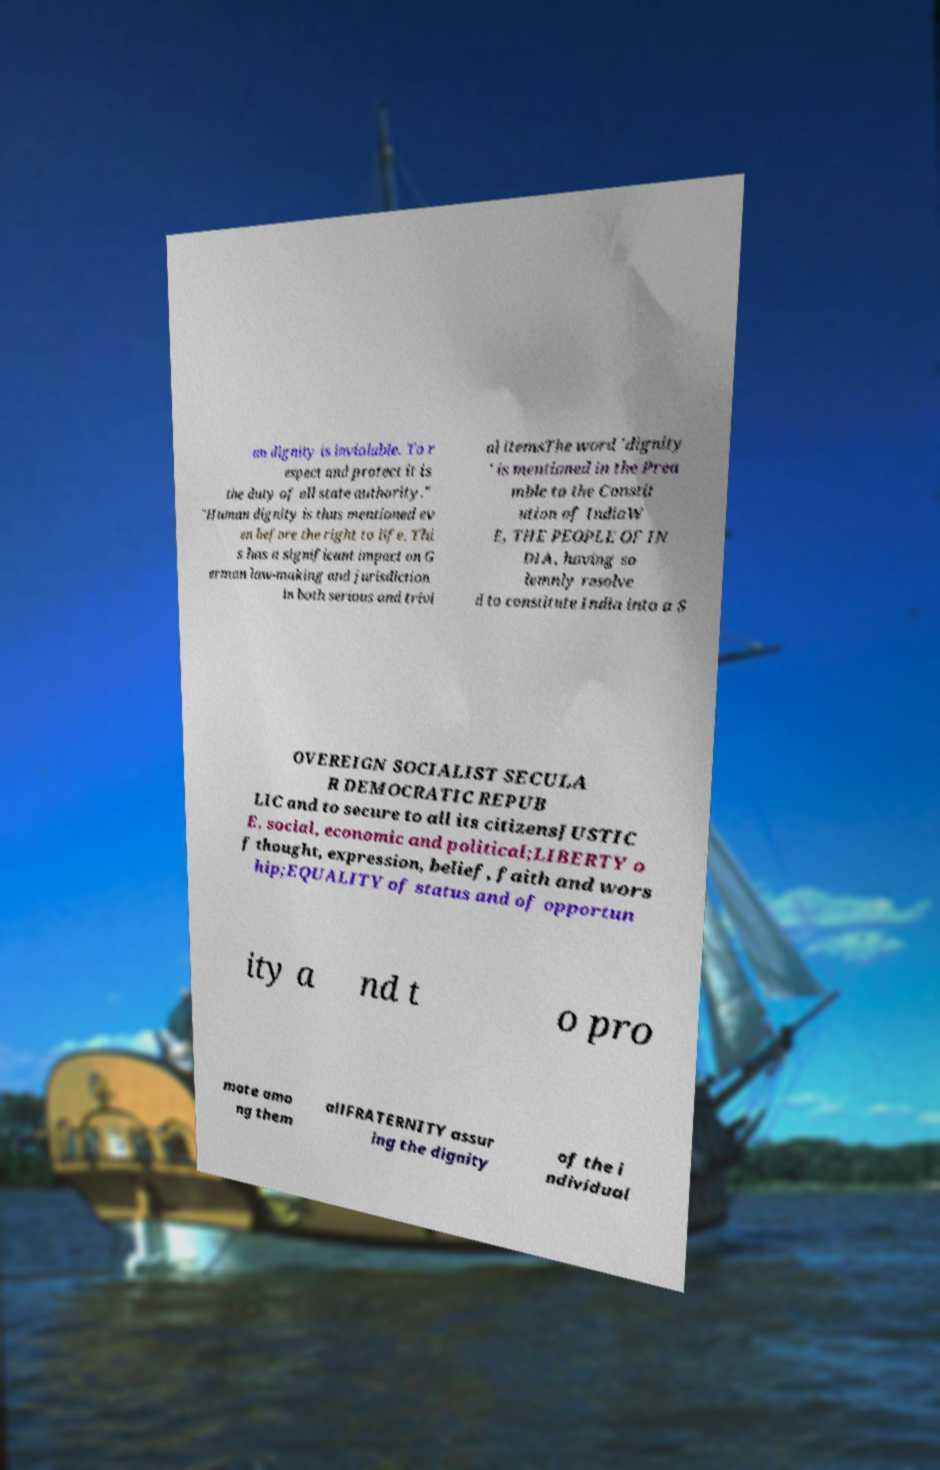Could you extract and type out the text from this image? an dignity is inviolable. To r espect and protect it is the duty of all state authority." "Human dignity is thus mentioned ev en before the right to life. Thi s has a significant impact on G erman law-making and jurisdiction in both serious and trivi al itemsThe word 'dignity ' is mentioned in the Prea mble to the Constit ution of IndiaW E, THE PEOPLE OF IN DIA, having so lemnly resolve d to constitute India into a S OVEREIGN SOCIALIST SECULA R DEMOCRATIC REPUB LIC and to secure to all its citizensJUSTIC E, social, economic and political;LIBERTY o f thought, expression, belief, faith and wors hip;EQUALITY of status and of opportun ity a nd t o pro mote amo ng them allFRATERNITY assur ing the dignity of the i ndividual 